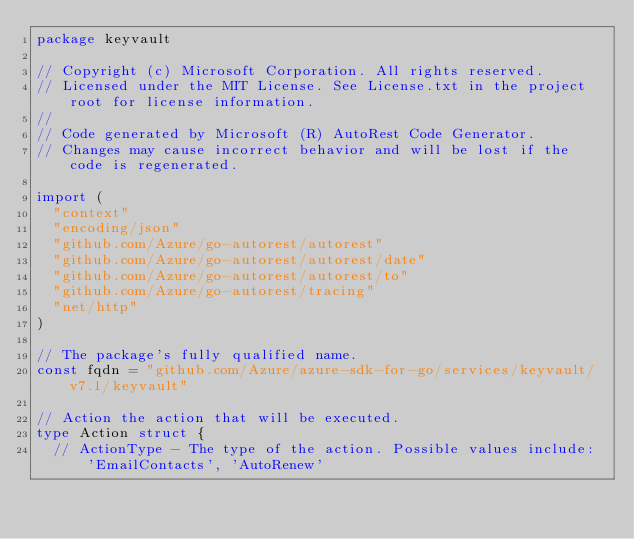<code> <loc_0><loc_0><loc_500><loc_500><_Go_>package keyvault

// Copyright (c) Microsoft Corporation. All rights reserved.
// Licensed under the MIT License. See License.txt in the project root for license information.
//
// Code generated by Microsoft (R) AutoRest Code Generator.
// Changes may cause incorrect behavior and will be lost if the code is regenerated.

import (
	"context"
	"encoding/json"
	"github.com/Azure/go-autorest/autorest"
	"github.com/Azure/go-autorest/autorest/date"
	"github.com/Azure/go-autorest/autorest/to"
	"github.com/Azure/go-autorest/tracing"
	"net/http"
)

// The package's fully qualified name.
const fqdn = "github.com/Azure/azure-sdk-for-go/services/keyvault/v7.1/keyvault"

// Action the action that will be executed.
type Action struct {
	// ActionType - The type of the action. Possible values include: 'EmailContacts', 'AutoRenew'</code> 